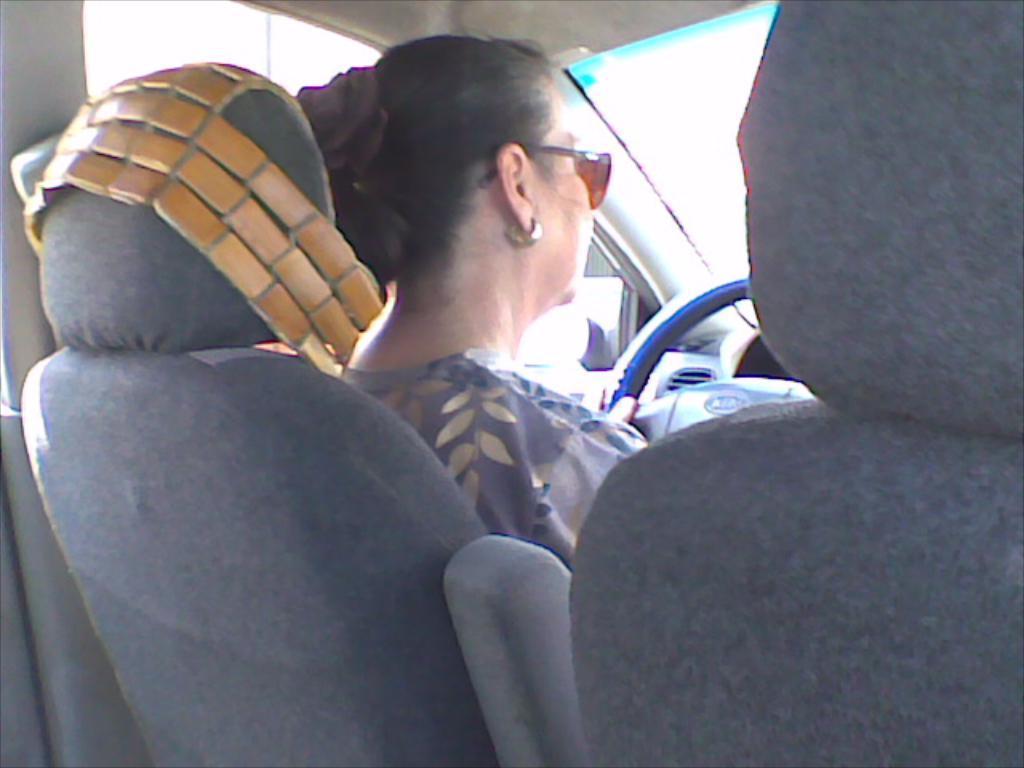How would you summarize this image in a sentence or two? In this image I can see the person sitting inside the vehicles and holding the steering. The person is wearing the grey color dress and specs. 